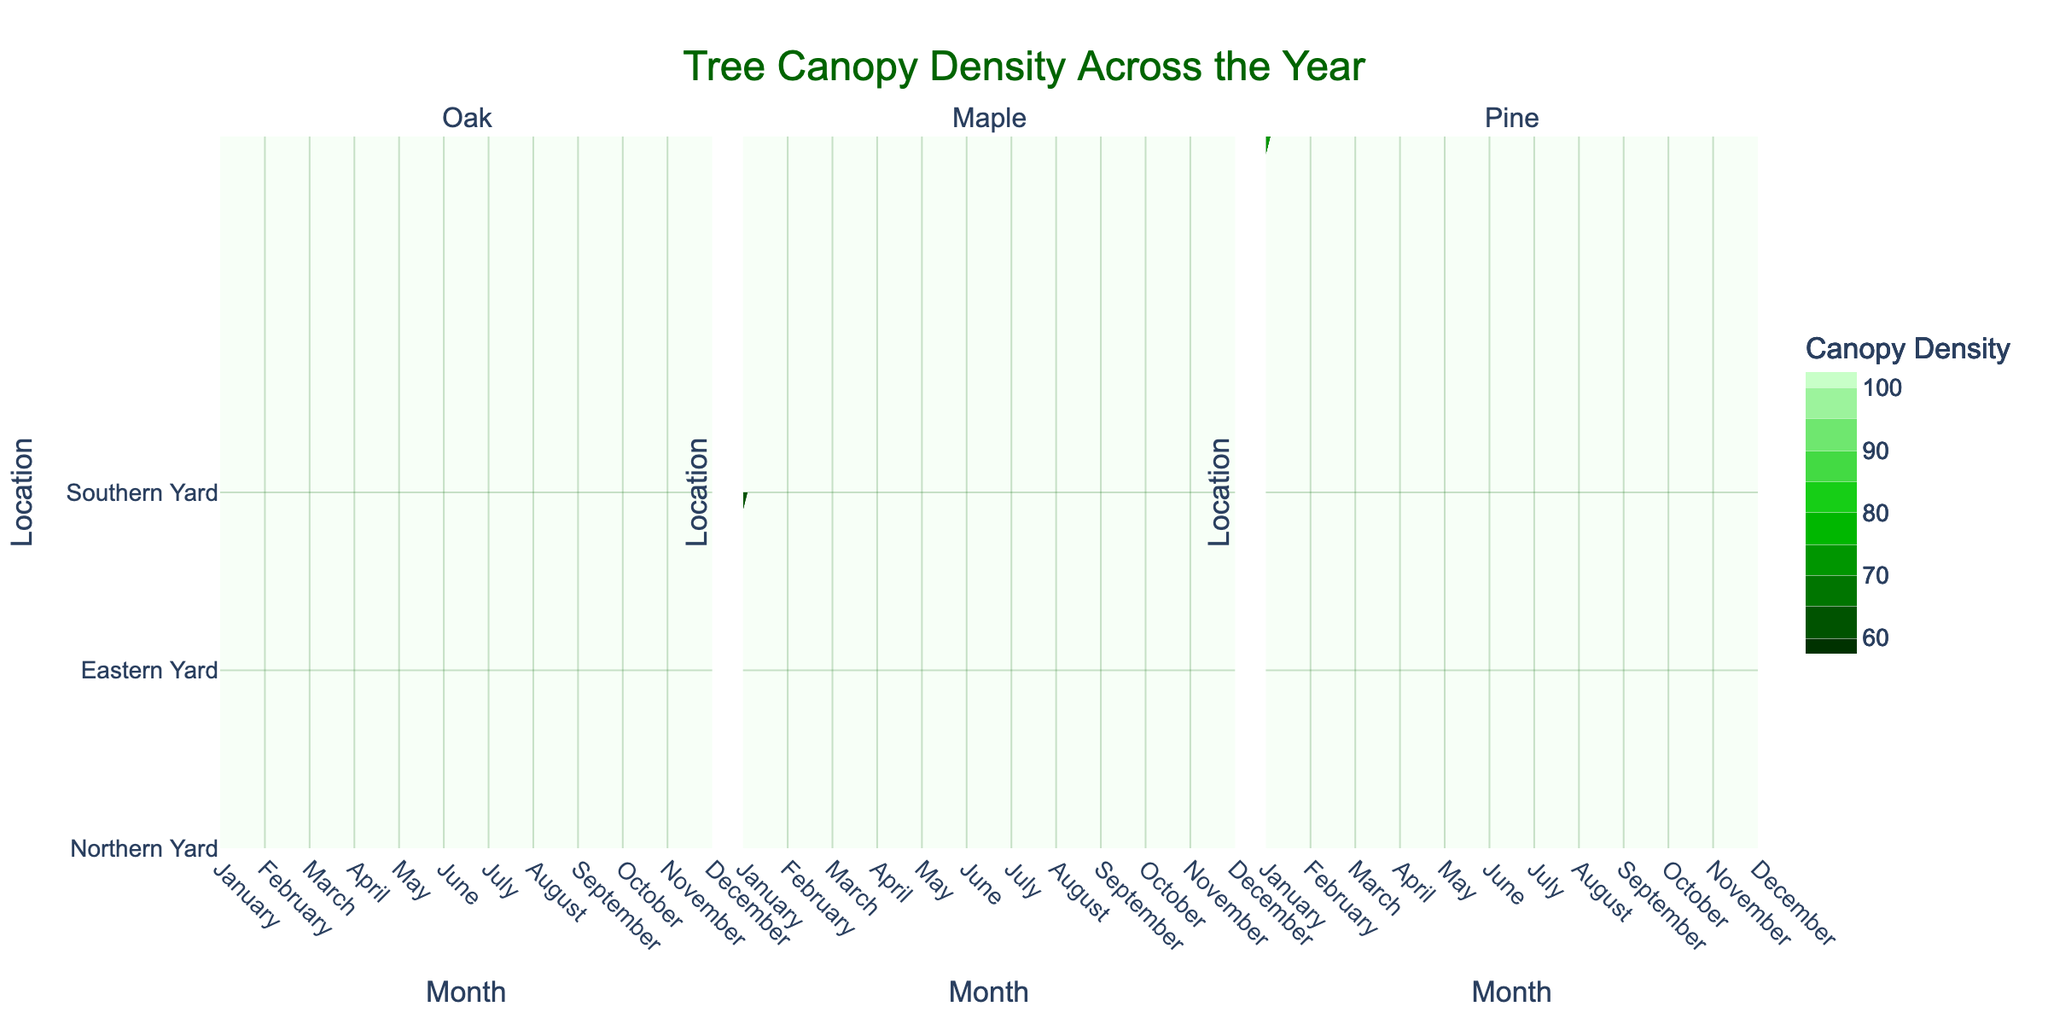What's the title of the figure? The title is usually displayed at the top of the figure. In this case, it is written in a large, green font.
Answer: Tree Canopy Density Across the Year How does the canopy density change for Oak trees from January to December? Look at the first subplot labeled 'Oak' and observe the contours along the months. The canopy density starts at 70 in January, increases monthly, peaks at 95 in July, and decreases back to 70 by December.
Answer: It follows an increasing and then decreasing trend Which location shows the highest canopy density for Maple trees? Check the subplot titled 'Maple' and observe the months where the contour lines representing higher canopy density (closer to 90) appear.
Answer: Eastern Yard In which month does Pine tree's canopy density peak and what's its value? Refer to the subplot titled 'Pine'. The highest contour line appears in April and May, representing the peak value of 90.
Answer: April and May, 90 Compare the shade patterns across the year for oak trees in the northern yard versus maple trees in the eastern yard. Use the contour lines of Oak and Maple subplots to compare. Oak's canopy density is highest in summer with corresponding Low shade patterns, whereas Maple also shows higher density in summer but with Low shade patterns during those months. Both show High shade in winter.
Answer: Both have High shade in winter and Low in summer, but their density values differ Which tree maintains the most consistent canopy density throughout the year? Assess the contour lines of each subplot. The Pine tree shows the least fluctuation, maintaining around 70-90 consistently.
Answer: Pine In which months do all the trees have 'High' shade patterns? From the contour subplots, observe the months where the shade pattern is visually indicated for 'High'. All trees show high shade in January, February, November, and December.
Answer: January, February, November, December What is the average canopy density of Maple trees during the summer months (June, July, August)? In the Maple subplot, observe the values for June, July, August and calculate the average: (90 + 90 + 85) / 3. The average is (265/3).
Answer: 88.33 What are the lowest and highest canopy density values for Pine trees and in which months do they occur? Check the Pine subplot to determine the range. The lowest canopy density is 70 in September and October; the highest is 90 in April and May.
Answer: Lowest: 70 (September, October); Highest: 90 (April, May) 